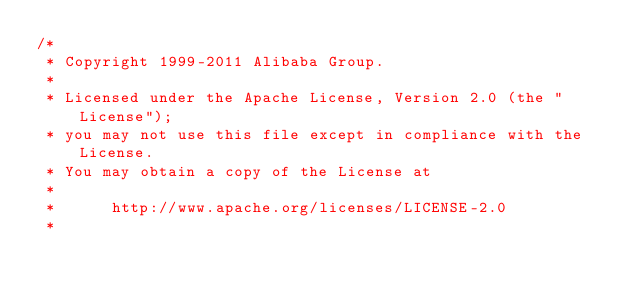Convert code to text. <code><loc_0><loc_0><loc_500><loc_500><_Java_>/*
 * Copyright 1999-2011 Alibaba Group.
 *  
 * Licensed under the Apache License, Version 2.0 (the "License");
 * you may not use this file except in compliance with the License.
 * You may obtain a copy of the License at
 *  
 *      http://www.apache.org/licenses/LICENSE-2.0
 *  </code> 